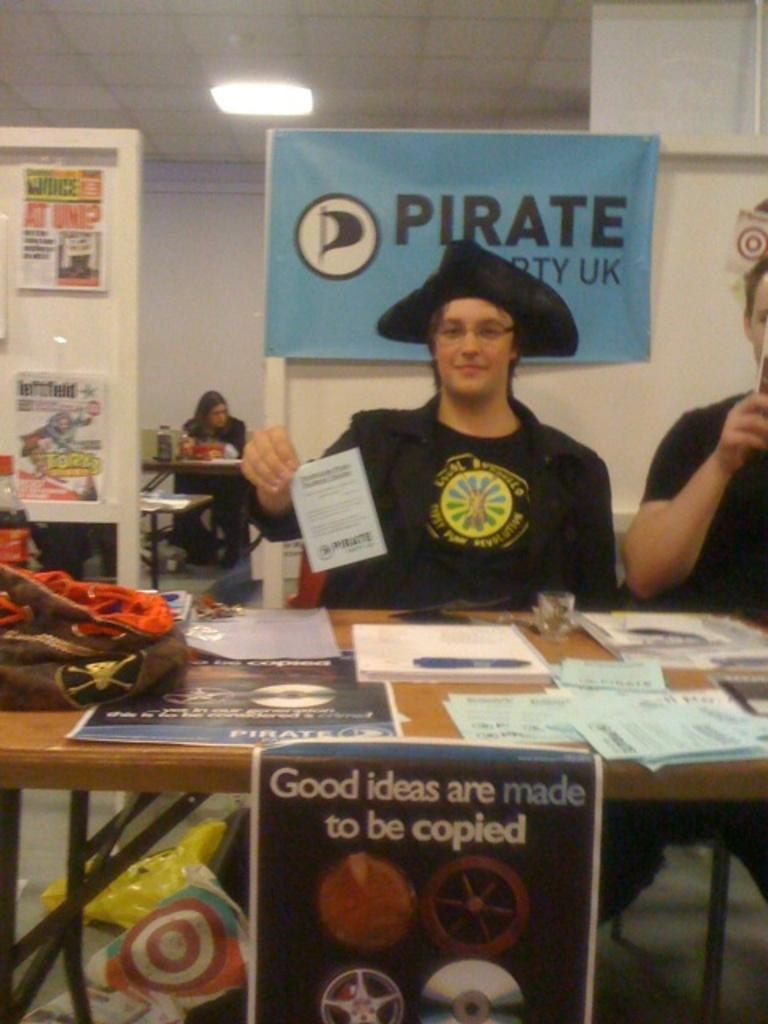<image>
Present a compact description of the photo's key features. A boy is dressed as a pirate at a table under a sign that says Pirate Party UK. 